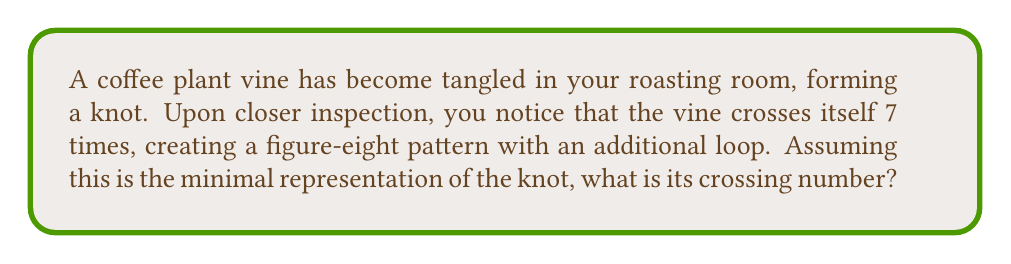Can you solve this math problem? To solve this problem, we need to understand the concept of crossing number in knot theory:

1. The crossing number of a knot is defined as the minimum number of crossings in any diagram of the knot.

2. In this case, we are told that the vine crosses itself 7 times, forming a figure-eight pattern with an additional loop.

3. The figure-eight knot is known to have a crossing number of 4.

4. The additional loop adds at least 3 more crossings to the figure-eight pattern.

5. We are given that this representation is minimal, meaning there is no way to reduce the number of crossings further.

6. Therefore, the crossing number of this knot is equal to the number of crossings we can observe: 7.

Mathematically, we can express this as:

$$\text{Crossing Number} = \text{Figure-Eight Crossings} + \text{Additional Loop Crossings}$$
$$\text{Crossing Number} = 4 + 3 = 7$$

This minimal representation ensures that the observed number of crossings is indeed the crossing number of the knot.
Answer: 7 